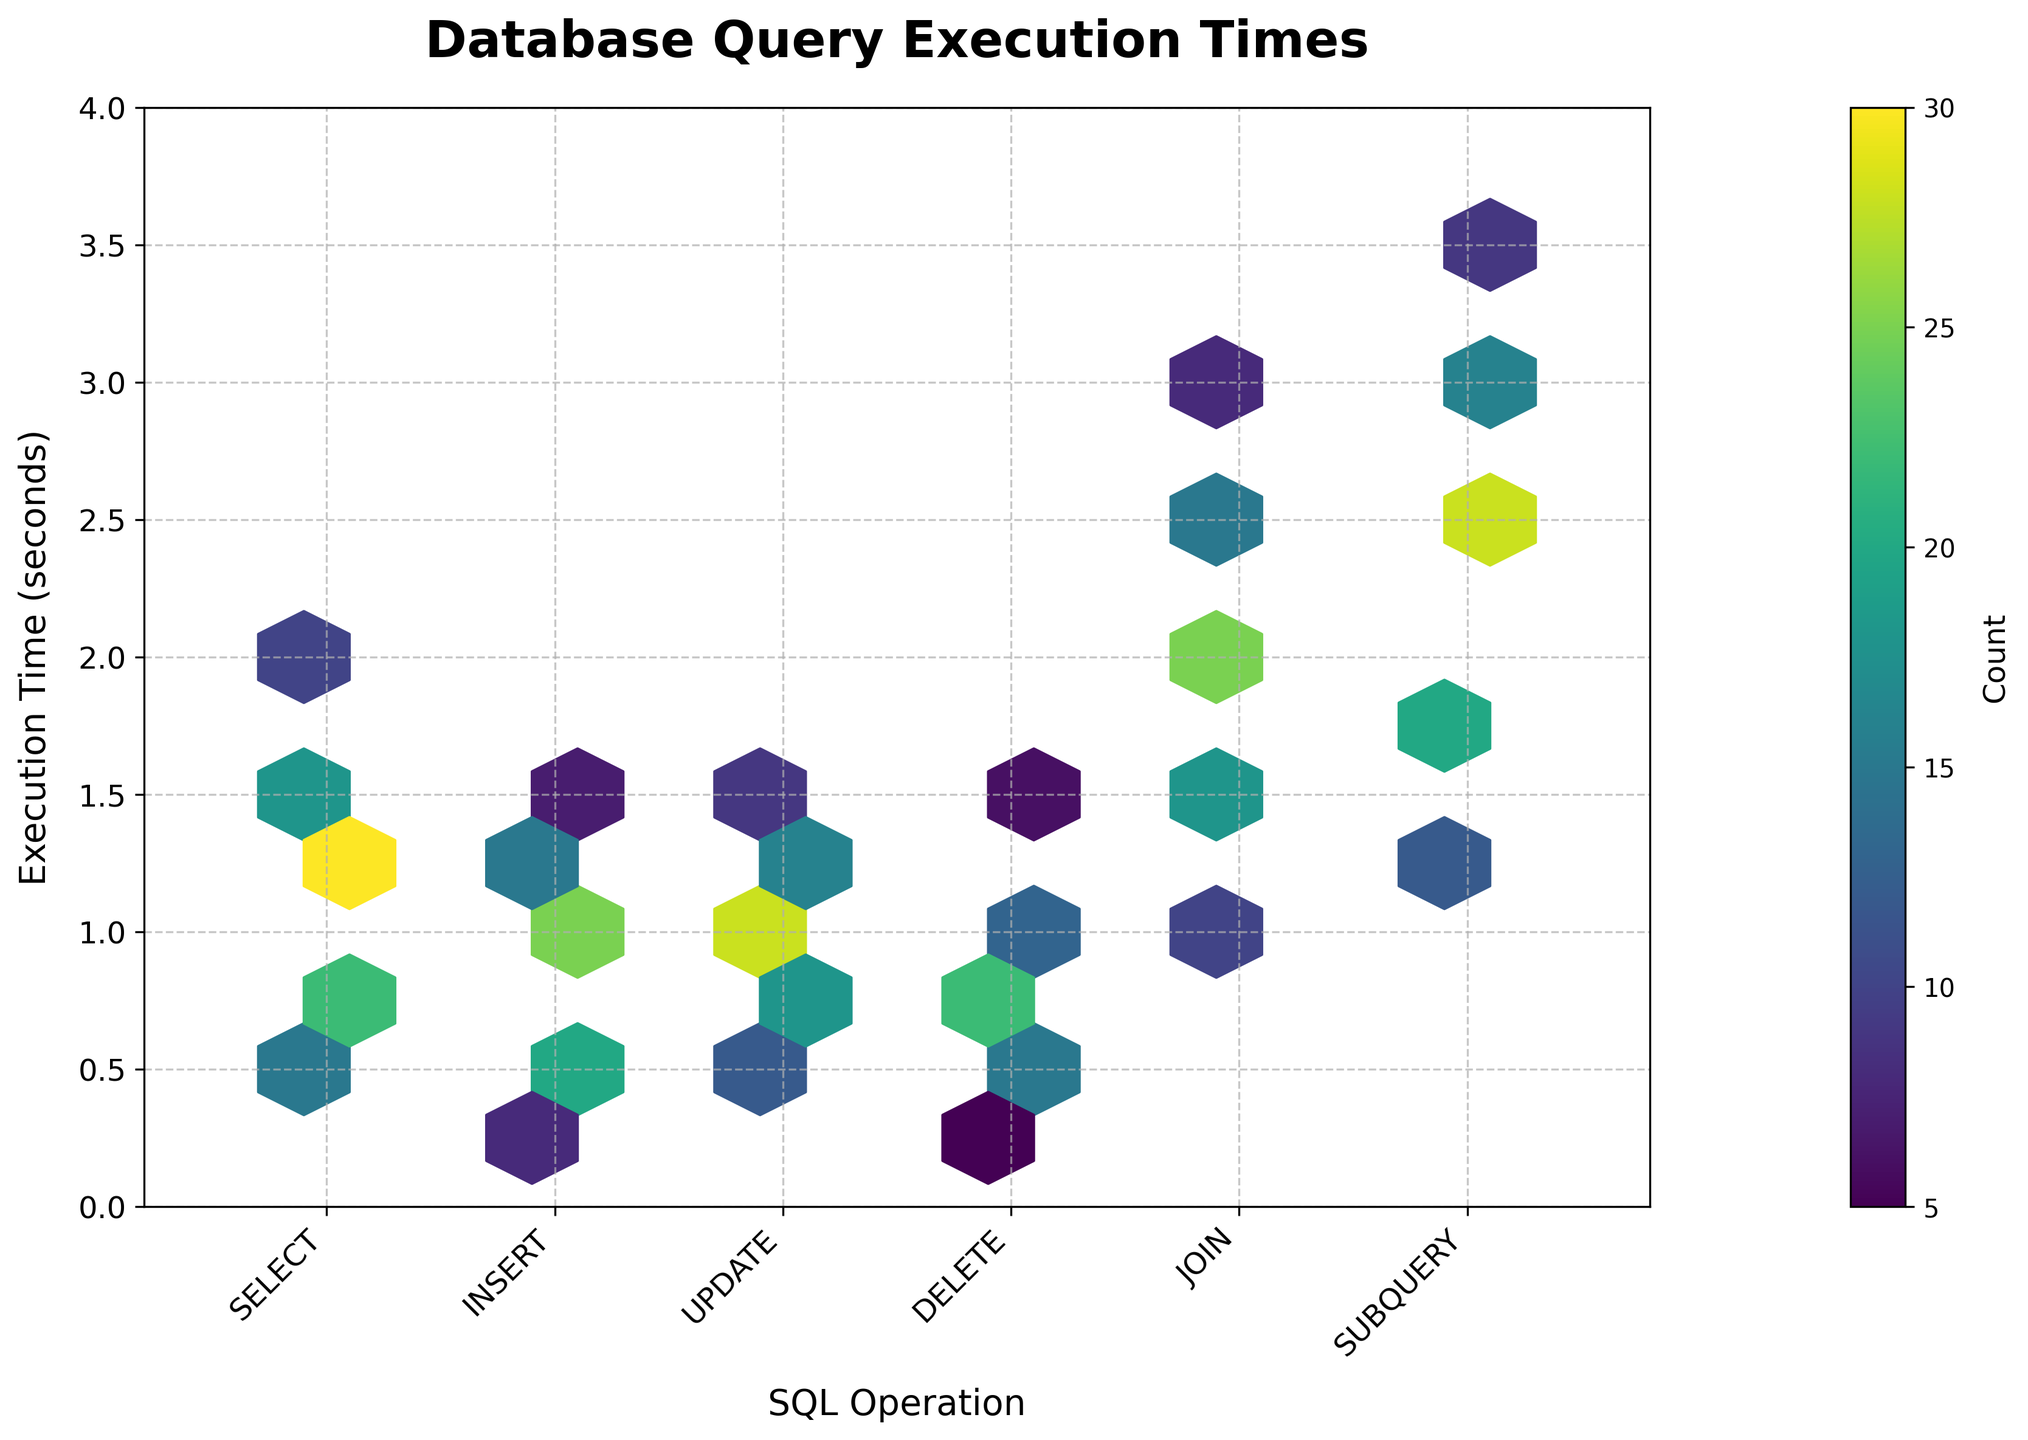What is the title of the plot? The title of the plot is located at the top center of the figure. It says "Database Query Execution Times".
Answer: Database Query Execution Times Which SQL operation has the shortest execution time depicted in the plot? By examining the x-axis labels and the y-axis values, the shortest execution time is seen in the "DELETE" operation, which went as low as 0.2 seconds.
Answer: DELETE How many SQL operations have their maximum execution time within 2 seconds? By checking the y-values for each SQL operation, we see that "SELECT", "INSERT", "UPDATE", and "DELETE" all have their highest execution times within 2 seconds, while "JOIN" and "SUBQUERY" extend beyond 2 seconds.
Answer: 4 What's the most frequent count value for the "SELECT" operation? The highest concentration of hexagons near the "SELECT" operation in y-values is at 1.2 seconds, where it peaks with a count of 30.
Answer: 30 Which SQL operation has hexagons with the highest count, and what is that count? The color bar helps identify counts. The "UPDATE" operation at 1.0 seconds has a hexagon with the highest color gradient, indicating a count of 28.
Answer: UPDATE, 28 Compare the count of the "INSERT" operation at 0.6 seconds with the "DELETE" operation at 1.1 seconds. Which one is higher, and by how much? The hexbin plot shows that the count for "INSERT" at 0.6 seconds is 20, while "DELETE" at 1.1 seconds is 13. Therefore, "INSERT" is higher by 7.
Answer: INSERT, 7 In which range of execution times do most "JOIN" operations fall? By examining the y-values and the concentration of hexagons, most "JOIN" operations are between 1.0 to 2.0 seconds.
Answer: 1.0 to 2.0 seconds Which SQL operation has the least amount of occurrences overall in the plot, and what might be the reason? By comparing the density of hexagons for each operation, "SUBQUERY" seems to have fewer occurrences overall. This might be because fewer subqueries are executed compared to other operations.
Answer: SUBQUERY How does the variation in execution times differ between "SELECT" and "SUBQUERY"? The "SELECT" operation has a more concentrated range (0.5 to 2.0 seconds), whereas "SUBQUERY" spans a broader range (1.2 to 3.6 seconds), indicating higher variability.
Answer: SELECT: less, SUBQUERY: more 